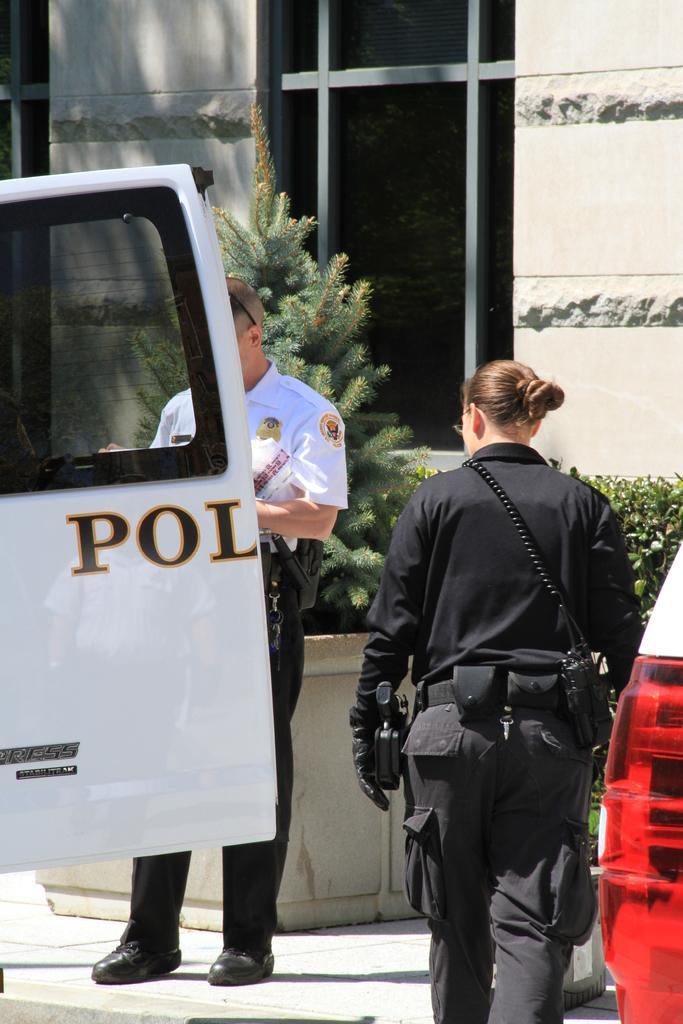Could you give a brief overview of what you see in this image? In this image there are two persons standing, there is a vehicle truncated towards the left of the image, there is a vehicle truncated towards the right of the image, there are plants behind the person, there is a wall truncated. 